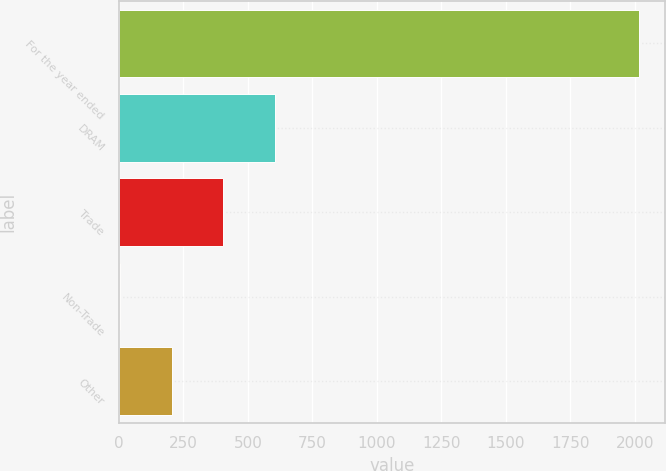Convert chart to OTSL. <chart><loc_0><loc_0><loc_500><loc_500><bar_chart><fcel>For the year ended<fcel>DRAM<fcel>Trade<fcel>Non-Trade<fcel>Other<nl><fcel>2015<fcel>606.6<fcel>405.4<fcel>3<fcel>204.2<nl></chart> 